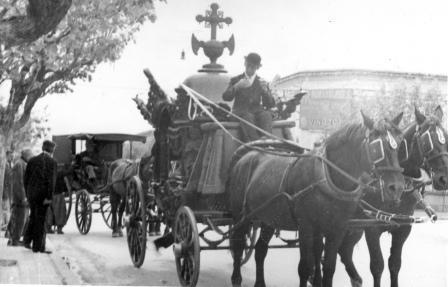How many horses are pulling the front carriage?
Give a very brief answer. 2. How many carriages?
Give a very brief answer. 2. How many horses can you see?
Give a very brief answer. 2. How many people can you see?
Give a very brief answer. 2. How many orange cars are there in the picture?
Give a very brief answer. 0. 